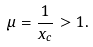<formula> <loc_0><loc_0><loc_500><loc_500>\mu = \frac { 1 } { x _ { c } } > 1 .</formula> 